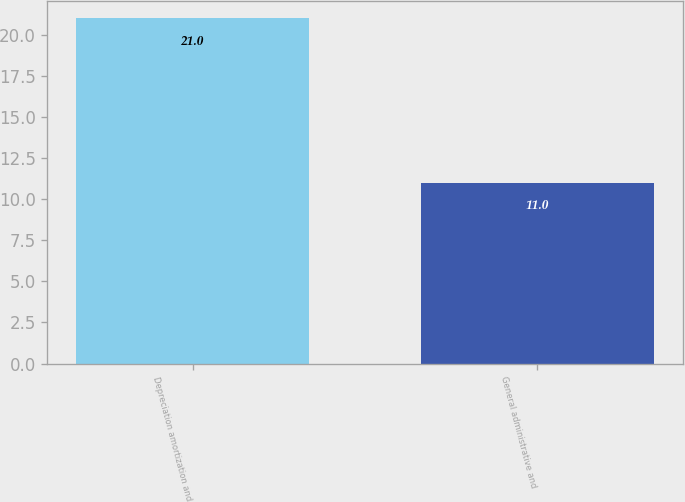Convert chart to OTSL. <chart><loc_0><loc_0><loc_500><loc_500><bar_chart><fcel>Depreciation amortization and<fcel>General administrative and<nl><fcel>21<fcel>11<nl></chart> 